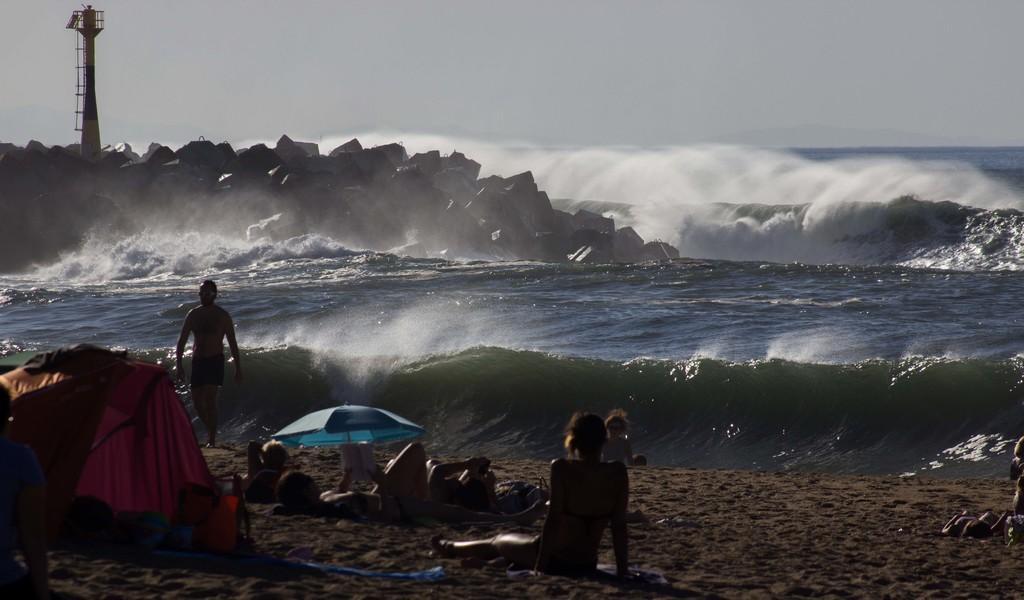Describe this image in one or two sentences. In the image it is a beach and in the foreground few people are lying on the sand, there is an umbrella and a tent on the sand surface, behind that there are huge waves of the sea and on the left side there is a lighthouse, around the light house there are many rocks. 